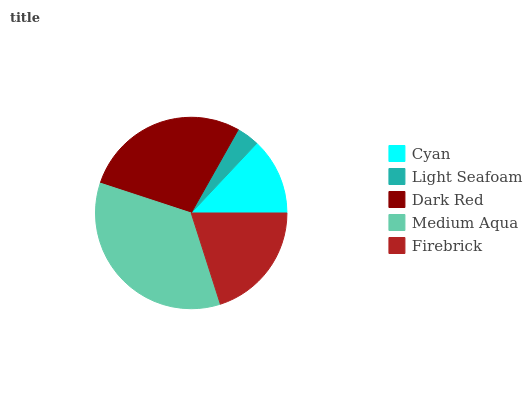Is Light Seafoam the minimum?
Answer yes or no. Yes. Is Medium Aqua the maximum?
Answer yes or no. Yes. Is Dark Red the minimum?
Answer yes or no. No. Is Dark Red the maximum?
Answer yes or no. No. Is Dark Red greater than Light Seafoam?
Answer yes or no. Yes. Is Light Seafoam less than Dark Red?
Answer yes or no. Yes. Is Light Seafoam greater than Dark Red?
Answer yes or no. No. Is Dark Red less than Light Seafoam?
Answer yes or no. No. Is Firebrick the high median?
Answer yes or no. Yes. Is Firebrick the low median?
Answer yes or no. Yes. Is Light Seafoam the high median?
Answer yes or no. No. Is Light Seafoam the low median?
Answer yes or no. No. 